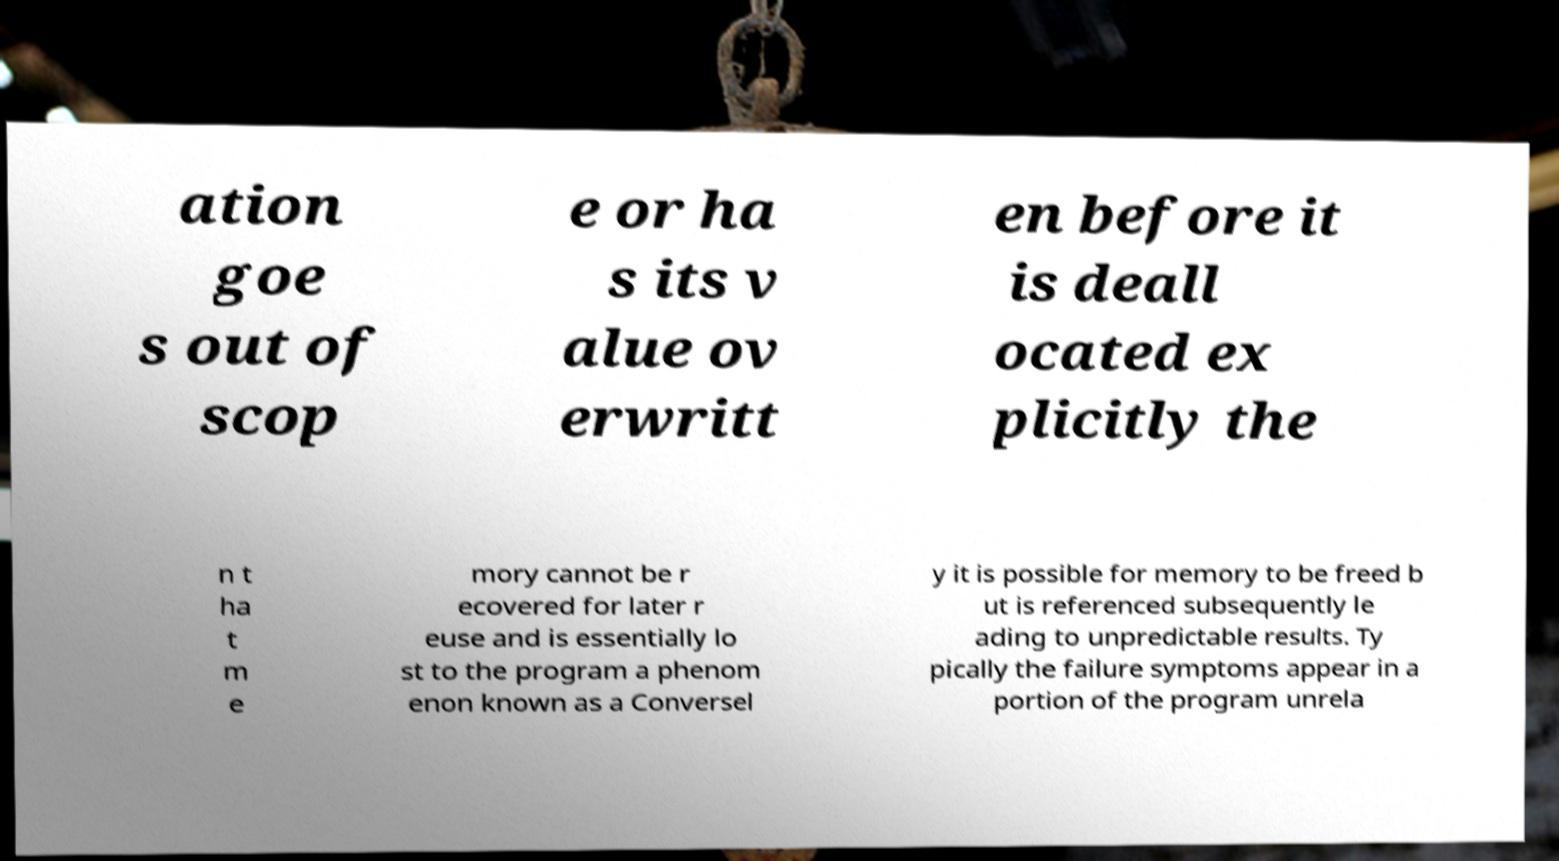Could you assist in decoding the text presented in this image and type it out clearly? ation goe s out of scop e or ha s its v alue ov erwritt en before it is deall ocated ex plicitly the n t ha t m e mory cannot be r ecovered for later r euse and is essentially lo st to the program a phenom enon known as a Conversel y it is possible for memory to be freed b ut is referenced subsequently le ading to unpredictable results. Ty pically the failure symptoms appear in a portion of the program unrela 